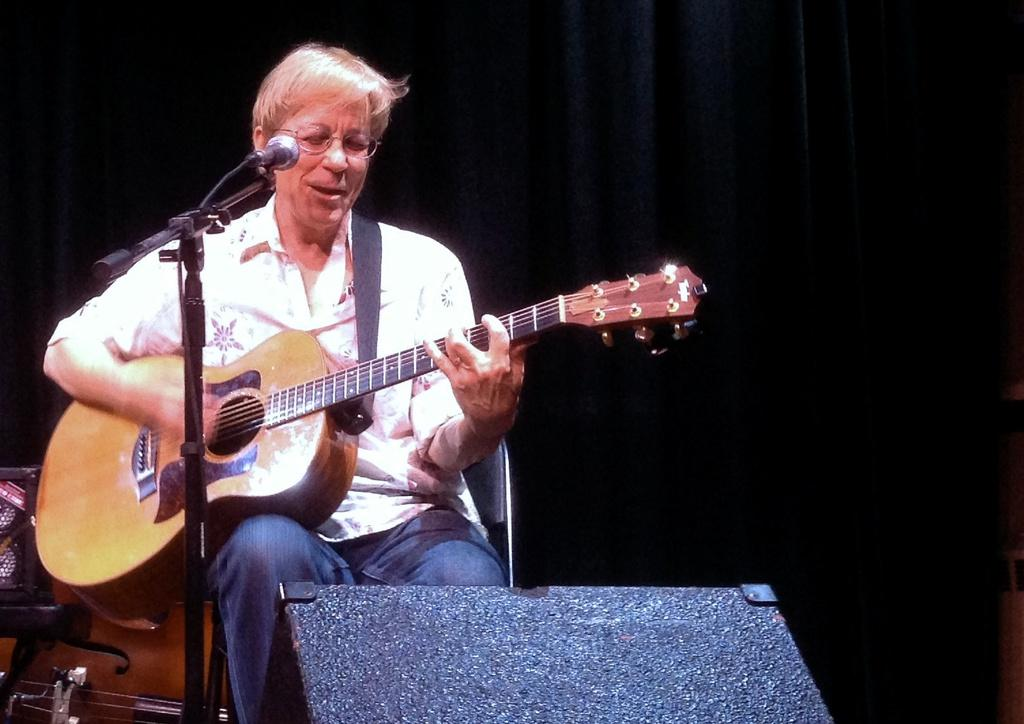What is the woman in the image doing? The woman is playing a guitar. What object is present in the image that is typically used for amplifying sound? There is a mic with a stand in the image. What type of engine can be seen powering the airplane in the image? There is no airplane present in the image, so it is not possible to determine what type of engine might be powering it. 